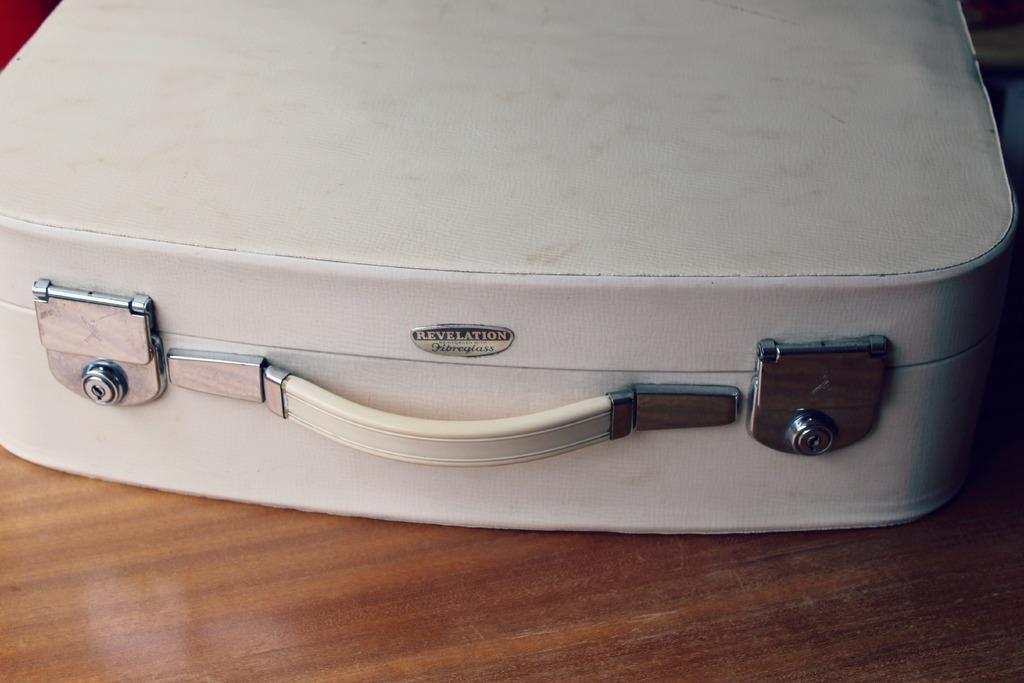Please provide a concise description of this image. In the image we can see there is a white colour suitcase kept on the wooden table. 